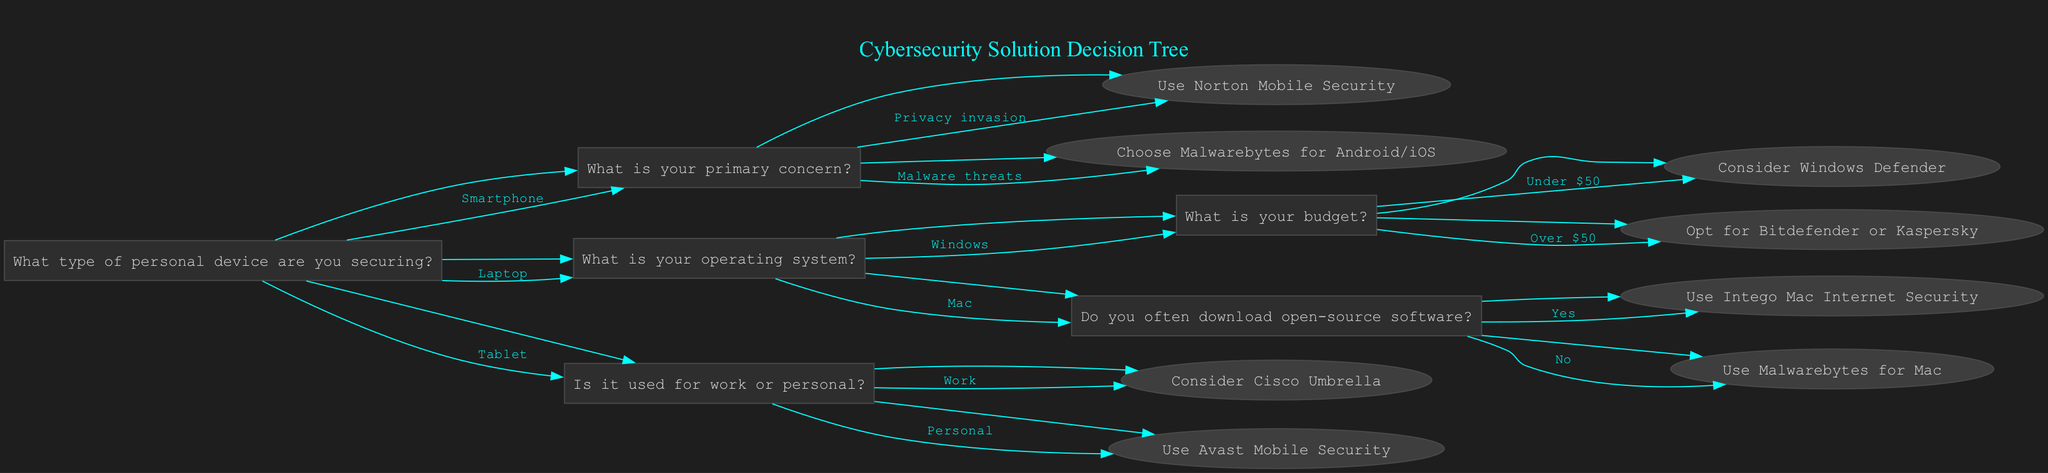What personal device type is the starting point of the decision tree? The root question of the decision tree asks about the type of personal device being secured, which includes options: Smartphone, Laptop, and Tablet.
Answer: Smartphone, Laptop, Tablet What is the recommended solution for a smartphone if my primary concern is malware threats? Following the path from the root, if the device is a Smartphone and the primary concern is malware threats, the recommendation is to choose Malwarebytes for Android/iOS.
Answer: Malwarebytes for Android/iOS How many total options are available for securing a laptop based on its operating system? The decision tree provides two main operating systems for laptops: Windows and Mac. Each has further options based on budget or downloading habits, representing a total of four options for a Laptop.
Answer: 4 Which recommendation is given if the laptop is a Mac and the user frequently downloads open-source software? If the laptop is a Mac, the next question assesses whether the user often downloads open-source software. Answering 'Yes' leads to the recommendation of using Intego Mac Internet Security.
Answer: Intego Mac Internet Security In the context of the decision tree, how many recommendations are available for a tablet used for personal purposes? The decision tree distinguishes between work and personal use for tablets. If used for personal purposes, the recommendation is Avast Mobile Security. There is one recommendation specifically for personal tablet use.
Answer: 1 What happens if the user's budget for a Windows laptop is over $50? If the user selects a Windows laptop and specifies a budget over $50, the recommendation will be either Bitdefender or Kaspersky, indicating that higher-tier security solutions are suggested for greater budget allocations.
Answer: Bitdefender or Kaspersky What is the sequence of questions when securing a laptop with a budget under $50? The flow starts with identifying the device as a Laptop, followed by the operating system as Windows, and subsequently leads to the budget question, where choosing under $50 results in the recommendation of Windows Defender.
Answer: Windows Defender What is the maximum number of recommendations provided for any device type in the diagram? The diagram contains one recommendation for smartphones (Norton Mobile Security or Malwarebytes), one for tablets used for work (Cisco Umbrella), two for Windows laptops, two for Mac laptops, and one for tablets used personally. The maximum at any node is two.
Answer: 2 If a tablet is used for work, what solution is recommended according to the tree? The decision tree indicates that if a tablet is indicated for work purposes, the recommended solution is Cisco Umbrella. The pathway leads directly to that recommendation based on the previous questions.
Answer: Cisco Umbrella 